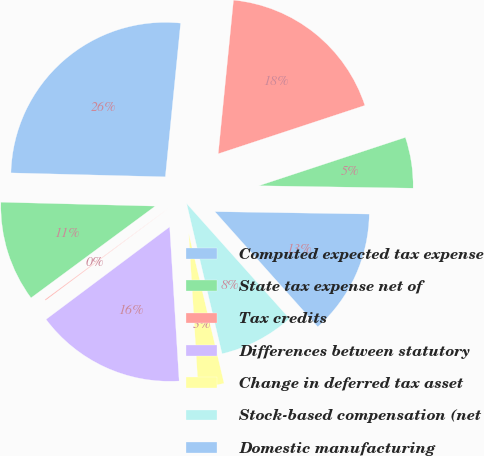Convert chart to OTSL. <chart><loc_0><loc_0><loc_500><loc_500><pie_chart><fcel>Computed expected tax expense<fcel>State tax expense net of<fcel>Tax credits<fcel>Differences between statutory<fcel>Change in deferred tax asset<fcel>Stock-based compensation (net<fcel>Domestic manufacturing<fcel>Other net<fcel>Provision for income taxes<nl><fcel>26.17%<fcel>10.53%<fcel>0.1%<fcel>15.75%<fcel>2.71%<fcel>7.92%<fcel>13.14%<fcel>5.32%<fcel>18.35%<nl></chart> 